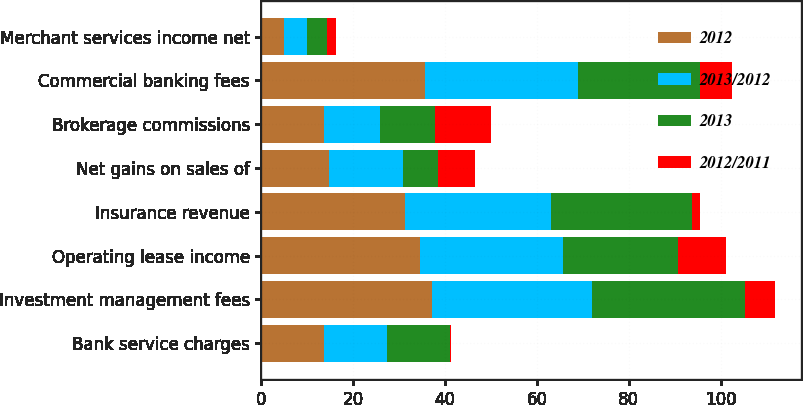Convert chart to OTSL. <chart><loc_0><loc_0><loc_500><loc_500><stacked_bar_chart><ecel><fcel>Bank service charges<fcel>Investment management fees<fcel>Operating lease income<fcel>Insurance revenue<fcel>Net gains on sales of<fcel>Brokerage commissions<fcel>Commercial banking fees<fcel>Merchant services income net<nl><fcel>2012<fcel>13.7<fcel>37.2<fcel>34.5<fcel>31.2<fcel>14.8<fcel>13.7<fcel>35.6<fcel>5<nl><fcel>2013/2012<fcel>13.7<fcel>34.9<fcel>31.2<fcel>31.8<fcel>16.1<fcel>12.2<fcel>33.3<fcel>4.9<nl><fcel>2013<fcel>13.7<fcel>33.2<fcel>25<fcel>30.7<fcel>7.6<fcel>11.9<fcel>26.6<fcel>4.3<nl><fcel>2012/2011<fcel>0.1<fcel>6.6<fcel>10.6<fcel>1.9<fcel>8.1<fcel>12.3<fcel>6.9<fcel>2<nl></chart> 